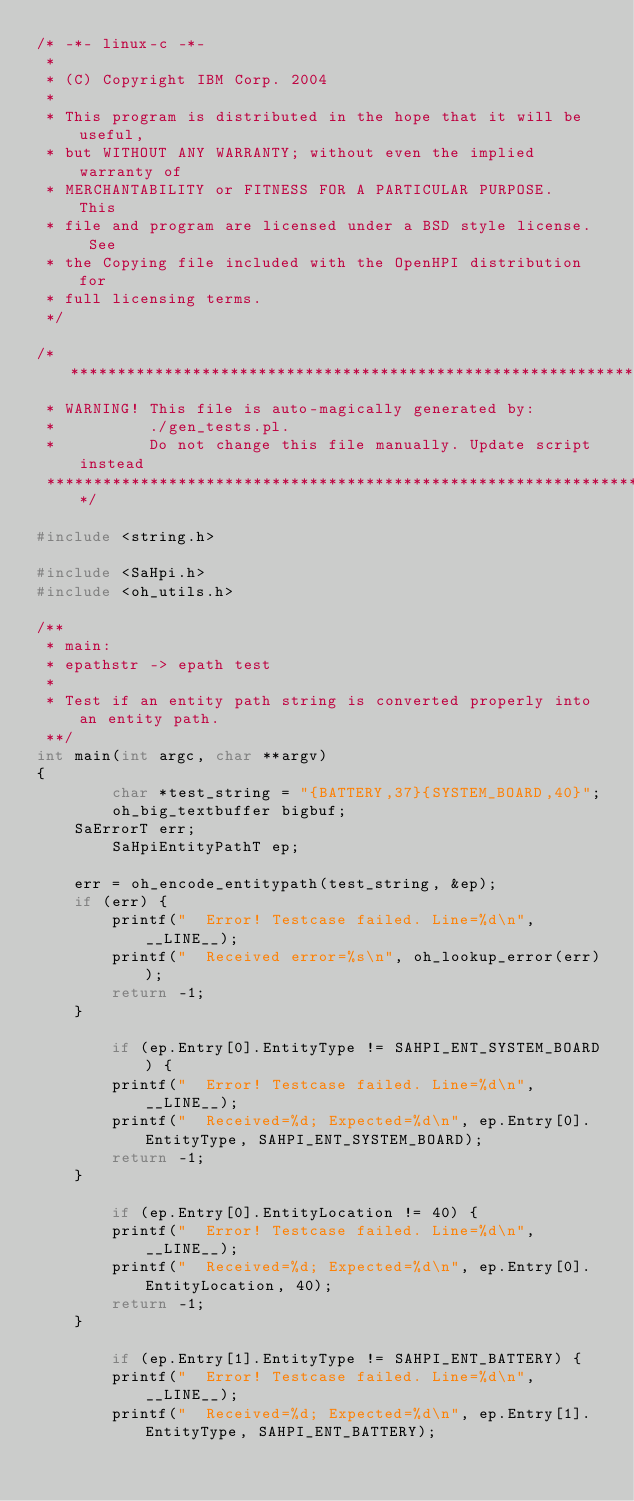Convert code to text. <code><loc_0><loc_0><loc_500><loc_500><_C_>/* -*- linux-c -*-
 * 
 * (C) Copyright IBM Corp. 2004
 *
 * This program is distributed in the hope that it will be useful,
 * but WITHOUT ANY WARRANTY; without even the implied warranty of
 * MERCHANTABILITY or FITNESS FOR A PARTICULAR PURPOSE.  This
 * file and program are licensed under a BSD style license.  See
 * the Copying file included with the OpenHPI distribution for
 * full licensing terms.
 */

/******************************************************************* 
 * WARNING! This file is auto-magically generated by:
 *          ./gen_tests.pl.
 *          Do not change this file manually. Update script instead
 *******************************************************************/

#include <string.h>

#include <SaHpi.h>
#include <oh_utils.h>

/**
 * main: 
 * epathstr -> epath test
 * 
 * Test if an entity path string is converted properly into an entity path.
 **/
int main(int argc, char **argv) 
{
        char *test_string = "{BATTERY,37}{SYSTEM_BOARD,40}";
        oh_big_textbuffer bigbuf;
	SaErrorT err;
        SaHpiEntityPathT ep;
        
	err = oh_encode_entitypath(test_string, &ep);
	if (err) {
		printf("  Error! Testcase failed. Line=%d\n", __LINE__);
		printf("  Received error=%s\n", oh_lookup_error(err));
		return -1;
	}
         
        if (ep.Entry[0].EntityType != SAHPI_ENT_SYSTEM_BOARD) {
	    printf("  Error! Testcase failed. Line=%d\n", __LINE__);
	    printf("  Received=%d; Expected=%d\n", ep.Entry[0].EntityType, SAHPI_ENT_SYSTEM_BOARD);
	    return -1;
	}
                
        if (ep.Entry[0].EntityLocation != 40) {
	    printf("  Error! Testcase failed. Line=%d\n", __LINE__);
	    printf("  Received=%d; Expected=%d\n", ep.Entry[0].EntityLocation, 40);
	    return -1;
	}
        
        if (ep.Entry[1].EntityType != SAHPI_ENT_BATTERY) {
	    printf("  Error! Testcase failed. Line=%d\n", __LINE__);
	    printf("  Received=%d; Expected=%d\n", ep.Entry[1].EntityType, SAHPI_ENT_BATTERY);</code> 